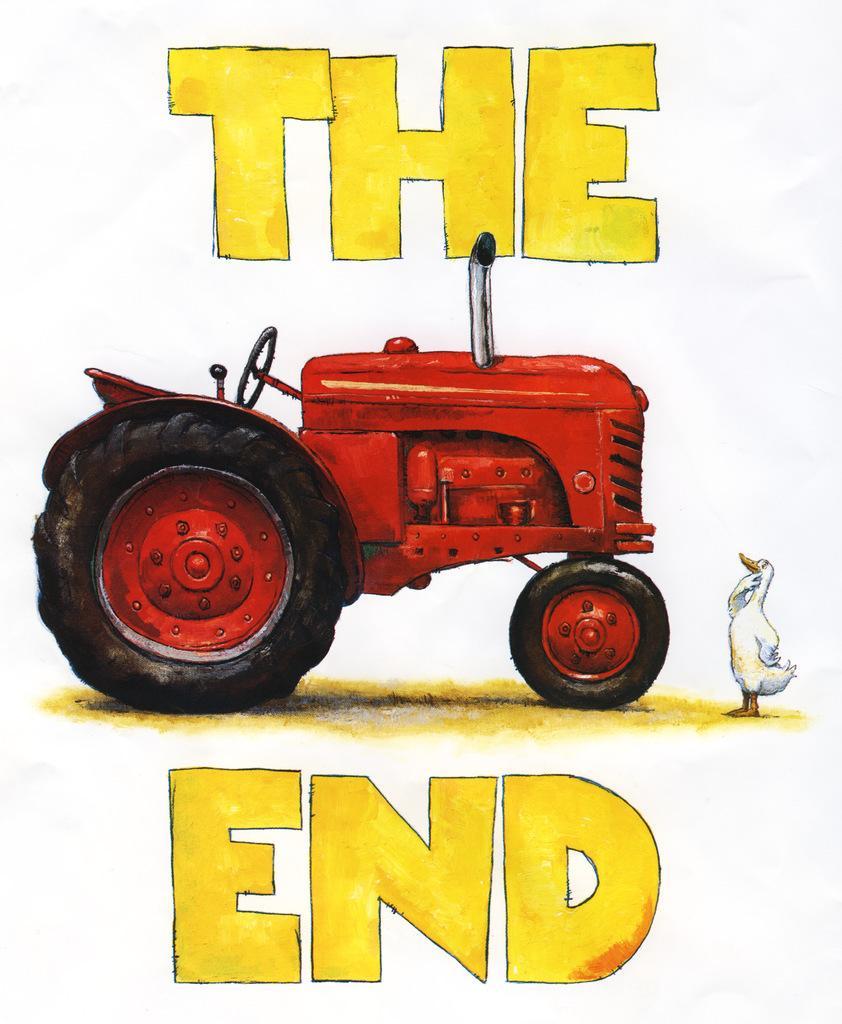Can you describe this image briefly? In the image in the center, we can see one paper. On the paper, we can see one bird and one tractor, which is in red color. On the paper, it is written as "The End". 